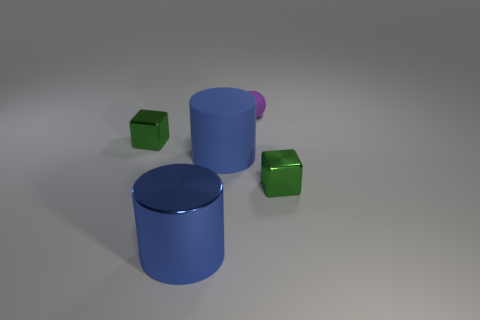Add 2 tiny green shiny things. How many objects exist? 7 Subtract 2 cylinders. How many cylinders are left? 0 Subtract all balls. How many objects are left? 4 Subtract all purple cylinders. Subtract all red balls. How many cylinders are left? 2 Subtract all blue rubber things. Subtract all small shiny cubes. How many objects are left? 2 Add 5 tiny matte objects. How many tiny matte objects are left? 6 Add 4 tiny green metallic spheres. How many tiny green metallic spheres exist? 4 Subtract 0 blue blocks. How many objects are left? 5 